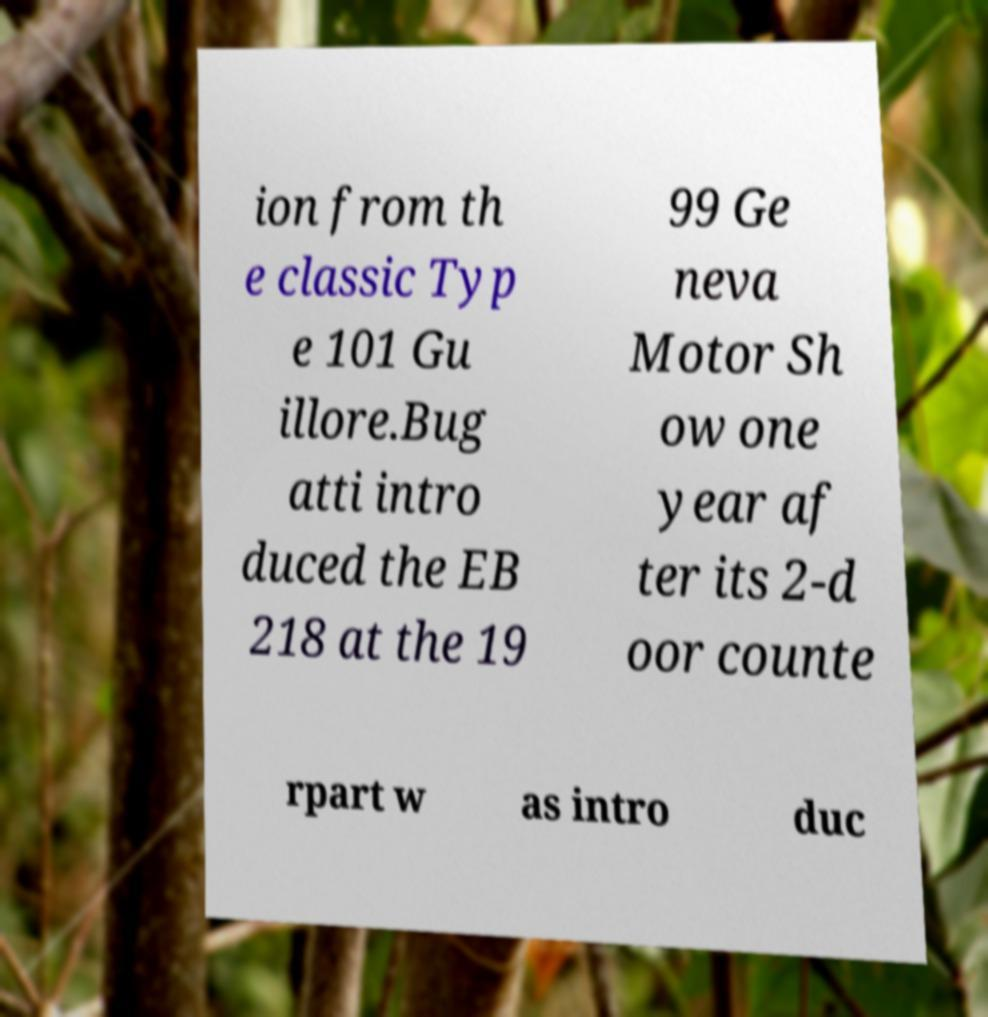I need the written content from this picture converted into text. Can you do that? ion from th e classic Typ e 101 Gu illore.Bug atti intro duced the EB 218 at the 19 99 Ge neva Motor Sh ow one year af ter its 2-d oor counte rpart w as intro duc 